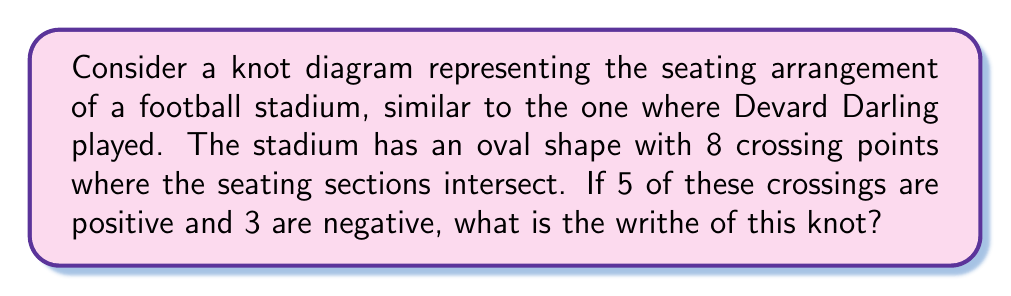Can you solve this math problem? To solve this problem, let's follow these steps:

1) Recall the definition of writhe:
   The writhe of a knot is the sum of the signs of its crossings in a diagram.

2) In our football stadium-shaped knot:
   - We have 8 total crossings
   - 5 of these crossings are positive (+1 each)
   - 3 of these crossings are negative (-1 each)

3) Let's calculate:
   $$\text{Writhe} = \sum_{i=1}^{n} \text{sign}(c_i)$$
   Where $c_i$ represents each crossing, and $n$ is the total number of crossings.

4) Substituting our values:
   $$\text{Writhe} = (+1 + +1 + +1 + +1 + +1) + (-1 + -1 + -1)$$

5) Simplifying:
   $$\text{Writhe} = 5 + (-3) = 2$$

Therefore, the writhe of this football stadium-shaped knot is 2.
Answer: 2 